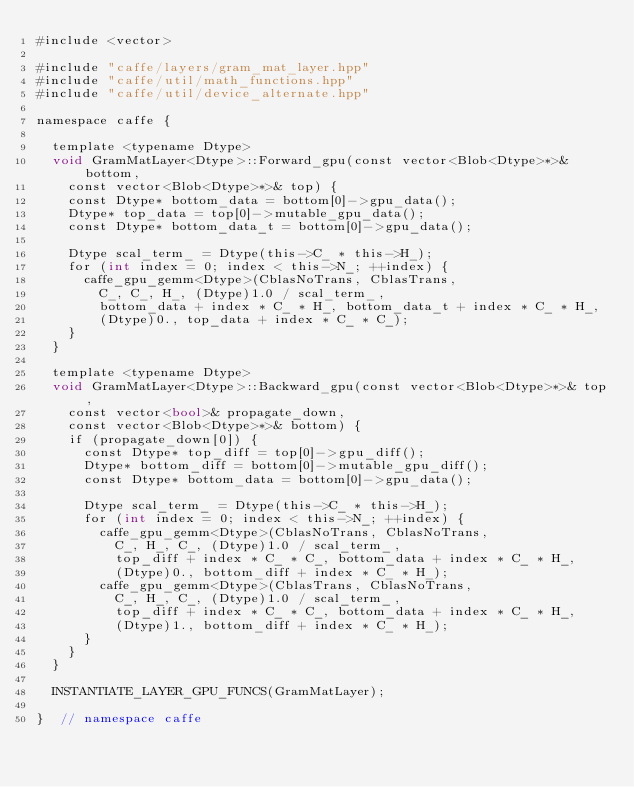Convert code to text. <code><loc_0><loc_0><loc_500><loc_500><_Cuda_>#include <vector>

#include "caffe/layers/gram_mat_layer.hpp"
#include "caffe/util/math_functions.hpp"
#include "caffe/util/device_alternate.hpp"

namespace caffe {

	template <typename Dtype>
	void GramMatLayer<Dtype>::Forward_gpu(const vector<Blob<Dtype>*>& bottom,
		const vector<Blob<Dtype>*>& top) {
		const Dtype* bottom_data = bottom[0]->gpu_data();
		Dtype* top_data = top[0]->mutable_gpu_data();
		const Dtype* bottom_data_t = bottom[0]->gpu_data();

		Dtype scal_term_ = Dtype(this->C_ * this->H_);
		for (int index = 0; index < this->N_; ++index) {
			caffe_gpu_gemm<Dtype>(CblasNoTrans, CblasTrans,
				C_, C_, H_, (Dtype)1.0 / scal_term_,
				bottom_data + index * C_ * H_, bottom_data_t + index * C_ * H_,
				(Dtype)0., top_data + index * C_ * C_);
		}
	}

	template <typename Dtype>
	void GramMatLayer<Dtype>::Backward_gpu(const vector<Blob<Dtype>*>& top,
		const vector<bool>& propagate_down,
		const vector<Blob<Dtype>*>& bottom) {
		if (propagate_down[0]) {
			const Dtype* top_diff = top[0]->gpu_diff();
			Dtype* bottom_diff = bottom[0]->mutable_gpu_diff();
			const Dtype* bottom_data = bottom[0]->gpu_data();

			Dtype scal_term_ = Dtype(this->C_ * this->H_);
			for (int index = 0; index < this->N_; ++index) {
				caffe_gpu_gemm<Dtype>(CblasNoTrans, CblasNoTrans,
					C_, H_, C_, (Dtype)1.0 / scal_term_,
					top_diff + index * C_ * C_, bottom_data + index * C_ * H_,
					(Dtype)0., bottom_diff + index * C_ * H_);
				caffe_gpu_gemm<Dtype>(CblasTrans, CblasNoTrans,
					C_, H_, C_, (Dtype)1.0 / scal_term_,
					top_diff + index * C_ * C_, bottom_data + index * C_ * H_,
					(Dtype)1., bottom_diff + index * C_ * H_);
			}
		}
	}

	INSTANTIATE_LAYER_GPU_FUNCS(GramMatLayer);

}  // namespace caffe
</code> 